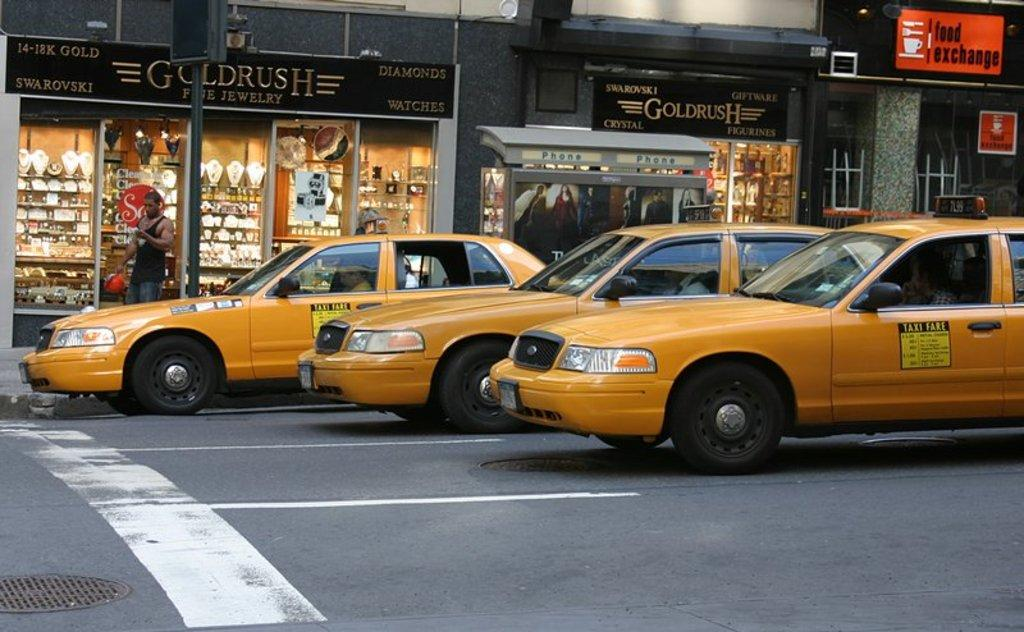<image>
Write a terse but informative summary of the picture. Gold Rush jewelry store features a selection of Swarovski crystal. 